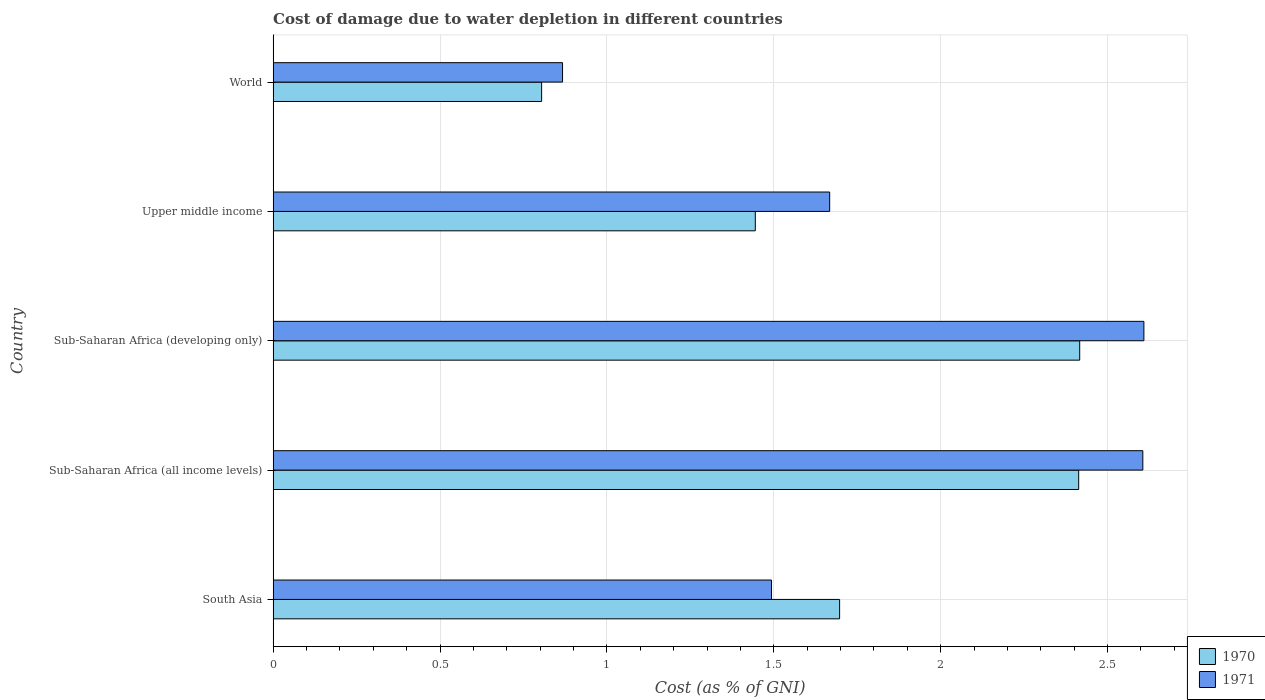How many different coloured bars are there?
Offer a very short reply. 2. Are the number of bars per tick equal to the number of legend labels?
Ensure brevity in your answer.  Yes. How many bars are there on the 2nd tick from the top?
Provide a short and direct response. 2. What is the label of the 4th group of bars from the top?
Make the answer very short. Sub-Saharan Africa (all income levels). What is the cost of damage caused due to water depletion in 1970 in South Asia?
Provide a succinct answer. 1.7. Across all countries, what is the maximum cost of damage caused due to water depletion in 1971?
Your answer should be compact. 2.61. Across all countries, what is the minimum cost of damage caused due to water depletion in 1971?
Keep it short and to the point. 0.87. In which country was the cost of damage caused due to water depletion in 1970 maximum?
Make the answer very short. Sub-Saharan Africa (developing only). What is the total cost of damage caused due to water depletion in 1970 in the graph?
Offer a very short reply. 8.78. What is the difference between the cost of damage caused due to water depletion in 1971 in Sub-Saharan Africa (developing only) and that in World?
Your answer should be compact. 1.74. What is the difference between the cost of damage caused due to water depletion in 1971 in Upper middle income and the cost of damage caused due to water depletion in 1970 in Sub-Saharan Africa (developing only)?
Keep it short and to the point. -0.75. What is the average cost of damage caused due to water depletion in 1971 per country?
Offer a terse response. 1.85. What is the difference between the cost of damage caused due to water depletion in 1971 and cost of damage caused due to water depletion in 1970 in South Asia?
Provide a short and direct response. -0.2. What is the ratio of the cost of damage caused due to water depletion in 1970 in Sub-Saharan Africa (all income levels) to that in Upper middle income?
Provide a succinct answer. 1.67. Is the cost of damage caused due to water depletion in 1970 in South Asia less than that in Upper middle income?
Make the answer very short. No. What is the difference between the highest and the second highest cost of damage caused due to water depletion in 1971?
Provide a short and direct response. 0. What is the difference between the highest and the lowest cost of damage caused due to water depletion in 1971?
Offer a terse response. 1.74. What does the 2nd bar from the top in Sub-Saharan Africa (all income levels) represents?
Ensure brevity in your answer.  1970. Are all the bars in the graph horizontal?
Offer a terse response. Yes. How many countries are there in the graph?
Your answer should be compact. 5. Does the graph contain any zero values?
Offer a terse response. No. Where does the legend appear in the graph?
Make the answer very short. Bottom right. What is the title of the graph?
Your response must be concise. Cost of damage due to water depletion in different countries. What is the label or title of the X-axis?
Your answer should be compact. Cost (as % of GNI). What is the Cost (as % of GNI) in 1970 in South Asia?
Your answer should be very brief. 1.7. What is the Cost (as % of GNI) of 1971 in South Asia?
Give a very brief answer. 1.49. What is the Cost (as % of GNI) in 1970 in Sub-Saharan Africa (all income levels)?
Ensure brevity in your answer.  2.41. What is the Cost (as % of GNI) of 1971 in Sub-Saharan Africa (all income levels)?
Offer a terse response. 2.61. What is the Cost (as % of GNI) of 1970 in Sub-Saharan Africa (developing only)?
Your answer should be compact. 2.42. What is the Cost (as % of GNI) of 1971 in Sub-Saharan Africa (developing only)?
Keep it short and to the point. 2.61. What is the Cost (as % of GNI) in 1970 in Upper middle income?
Make the answer very short. 1.44. What is the Cost (as % of GNI) in 1971 in Upper middle income?
Provide a succinct answer. 1.67. What is the Cost (as % of GNI) of 1970 in World?
Keep it short and to the point. 0.8. What is the Cost (as % of GNI) in 1971 in World?
Offer a very short reply. 0.87. Across all countries, what is the maximum Cost (as % of GNI) in 1970?
Keep it short and to the point. 2.42. Across all countries, what is the maximum Cost (as % of GNI) in 1971?
Your response must be concise. 2.61. Across all countries, what is the minimum Cost (as % of GNI) of 1970?
Your response must be concise. 0.8. Across all countries, what is the minimum Cost (as % of GNI) in 1971?
Keep it short and to the point. 0.87. What is the total Cost (as % of GNI) of 1970 in the graph?
Give a very brief answer. 8.78. What is the total Cost (as % of GNI) in 1971 in the graph?
Offer a very short reply. 9.24. What is the difference between the Cost (as % of GNI) in 1970 in South Asia and that in Sub-Saharan Africa (all income levels)?
Make the answer very short. -0.72. What is the difference between the Cost (as % of GNI) in 1971 in South Asia and that in Sub-Saharan Africa (all income levels)?
Your answer should be very brief. -1.11. What is the difference between the Cost (as % of GNI) of 1970 in South Asia and that in Sub-Saharan Africa (developing only)?
Your answer should be very brief. -0.72. What is the difference between the Cost (as % of GNI) in 1971 in South Asia and that in Sub-Saharan Africa (developing only)?
Provide a succinct answer. -1.12. What is the difference between the Cost (as % of GNI) in 1970 in South Asia and that in Upper middle income?
Offer a very short reply. 0.25. What is the difference between the Cost (as % of GNI) of 1971 in South Asia and that in Upper middle income?
Offer a very short reply. -0.17. What is the difference between the Cost (as % of GNI) in 1970 in South Asia and that in World?
Your response must be concise. 0.89. What is the difference between the Cost (as % of GNI) of 1971 in South Asia and that in World?
Provide a succinct answer. 0.63. What is the difference between the Cost (as % of GNI) of 1970 in Sub-Saharan Africa (all income levels) and that in Sub-Saharan Africa (developing only)?
Offer a terse response. -0. What is the difference between the Cost (as % of GNI) of 1971 in Sub-Saharan Africa (all income levels) and that in Sub-Saharan Africa (developing only)?
Give a very brief answer. -0. What is the difference between the Cost (as % of GNI) of 1970 in Sub-Saharan Africa (all income levels) and that in Upper middle income?
Your response must be concise. 0.97. What is the difference between the Cost (as % of GNI) in 1971 in Sub-Saharan Africa (all income levels) and that in Upper middle income?
Your answer should be compact. 0.94. What is the difference between the Cost (as % of GNI) of 1970 in Sub-Saharan Africa (all income levels) and that in World?
Provide a succinct answer. 1.61. What is the difference between the Cost (as % of GNI) in 1971 in Sub-Saharan Africa (all income levels) and that in World?
Give a very brief answer. 1.74. What is the difference between the Cost (as % of GNI) in 1970 in Sub-Saharan Africa (developing only) and that in Upper middle income?
Your answer should be very brief. 0.97. What is the difference between the Cost (as % of GNI) of 1971 in Sub-Saharan Africa (developing only) and that in Upper middle income?
Your answer should be compact. 0.94. What is the difference between the Cost (as % of GNI) in 1970 in Sub-Saharan Africa (developing only) and that in World?
Ensure brevity in your answer.  1.61. What is the difference between the Cost (as % of GNI) in 1971 in Sub-Saharan Africa (developing only) and that in World?
Your answer should be very brief. 1.74. What is the difference between the Cost (as % of GNI) in 1970 in Upper middle income and that in World?
Provide a succinct answer. 0.64. What is the difference between the Cost (as % of GNI) of 1971 in Upper middle income and that in World?
Your answer should be compact. 0.8. What is the difference between the Cost (as % of GNI) in 1970 in South Asia and the Cost (as % of GNI) in 1971 in Sub-Saharan Africa (all income levels)?
Keep it short and to the point. -0.91. What is the difference between the Cost (as % of GNI) in 1970 in South Asia and the Cost (as % of GNI) in 1971 in Sub-Saharan Africa (developing only)?
Make the answer very short. -0.91. What is the difference between the Cost (as % of GNI) in 1970 in South Asia and the Cost (as % of GNI) in 1971 in Upper middle income?
Your answer should be compact. 0.03. What is the difference between the Cost (as % of GNI) in 1970 in South Asia and the Cost (as % of GNI) in 1971 in World?
Your answer should be compact. 0.83. What is the difference between the Cost (as % of GNI) of 1970 in Sub-Saharan Africa (all income levels) and the Cost (as % of GNI) of 1971 in Sub-Saharan Africa (developing only)?
Give a very brief answer. -0.2. What is the difference between the Cost (as % of GNI) of 1970 in Sub-Saharan Africa (all income levels) and the Cost (as % of GNI) of 1971 in Upper middle income?
Offer a very short reply. 0.75. What is the difference between the Cost (as % of GNI) of 1970 in Sub-Saharan Africa (all income levels) and the Cost (as % of GNI) of 1971 in World?
Offer a very short reply. 1.55. What is the difference between the Cost (as % of GNI) in 1970 in Sub-Saharan Africa (developing only) and the Cost (as % of GNI) in 1971 in Upper middle income?
Ensure brevity in your answer.  0.75. What is the difference between the Cost (as % of GNI) of 1970 in Sub-Saharan Africa (developing only) and the Cost (as % of GNI) of 1971 in World?
Give a very brief answer. 1.55. What is the difference between the Cost (as % of GNI) in 1970 in Upper middle income and the Cost (as % of GNI) in 1971 in World?
Provide a short and direct response. 0.58. What is the average Cost (as % of GNI) in 1970 per country?
Offer a terse response. 1.76. What is the average Cost (as % of GNI) in 1971 per country?
Ensure brevity in your answer.  1.85. What is the difference between the Cost (as % of GNI) in 1970 and Cost (as % of GNI) in 1971 in South Asia?
Make the answer very short. 0.2. What is the difference between the Cost (as % of GNI) of 1970 and Cost (as % of GNI) of 1971 in Sub-Saharan Africa (all income levels)?
Provide a succinct answer. -0.19. What is the difference between the Cost (as % of GNI) in 1970 and Cost (as % of GNI) in 1971 in Sub-Saharan Africa (developing only)?
Your answer should be very brief. -0.19. What is the difference between the Cost (as % of GNI) of 1970 and Cost (as % of GNI) of 1971 in Upper middle income?
Your response must be concise. -0.22. What is the difference between the Cost (as % of GNI) of 1970 and Cost (as % of GNI) of 1971 in World?
Provide a short and direct response. -0.06. What is the ratio of the Cost (as % of GNI) of 1970 in South Asia to that in Sub-Saharan Africa (all income levels)?
Your answer should be very brief. 0.7. What is the ratio of the Cost (as % of GNI) of 1971 in South Asia to that in Sub-Saharan Africa (all income levels)?
Keep it short and to the point. 0.57. What is the ratio of the Cost (as % of GNI) in 1970 in South Asia to that in Sub-Saharan Africa (developing only)?
Offer a very short reply. 0.7. What is the ratio of the Cost (as % of GNI) in 1971 in South Asia to that in Sub-Saharan Africa (developing only)?
Provide a short and direct response. 0.57. What is the ratio of the Cost (as % of GNI) of 1970 in South Asia to that in Upper middle income?
Give a very brief answer. 1.17. What is the ratio of the Cost (as % of GNI) of 1971 in South Asia to that in Upper middle income?
Offer a terse response. 0.9. What is the ratio of the Cost (as % of GNI) of 1970 in South Asia to that in World?
Give a very brief answer. 2.11. What is the ratio of the Cost (as % of GNI) of 1971 in South Asia to that in World?
Provide a succinct answer. 1.72. What is the ratio of the Cost (as % of GNI) of 1971 in Sub-Saharan Africa (all income levels) to that in Sub-Saharan Africa (developing only)?
Ensure brevity in your answer.  1. What is the ratio of the Cost (as % of GNI) of 1970 in Sub-Saharan Africa (all income levels) to that in Upper middle income?
Offer a terse response. 1.67. What is the ratio of the Cost (as % of GNI) in 1971 in Sub-Saharan Africa (all income levels) to that in Upper middle income?
Offer a terse response. 1.56. What is the ratio of the Cost (as % of GNI) in 1970 in Sub-Saharan Africa (all income levels) to that in World?
Provide a short and direct response. 3. What is the ratio of the Cost (as % of GNI) in 1971 in Sub-Saharan Africa (all income levels) to that in World?
Your answer should be compact. 3. What is the ratio of the Cost (as % of GNI) in 1970 in Sub-Saharan Africa (developing only) to that in Upper middle income?
Your response must be concise. 1.67. What is the ratio of the Cost (as % of GNI) of 1971 in Sub-Saharan Africa (developing only) to that in Upper middle income?
Provide a short and direct response. 1.56. What is the ratio of the Cost (as % of GNI) in 1970 in Sub-Saharan Africa (developing only) to that in World?
Your answer should be very brief. 3. What is the ratio of the Cost (as % of GNI) in 1971 in Sub-Saharan Africa (developing only) to that in World?
Keep it short and to the point. 3.01. What is the ratio of the Cost (as % of GNI) in 1970 in Upper middle income to that in World?
Ensure brevity in your answer.  1.8. What is the ratio of the Cost (as % of GNI) of 1971 in Upper middle income to that in World?
Keep it short and to the point. 1.92. What is the difference between the highest and the second highest Cost (as % of GNI) in 1970?
Provide a succinct answer. 0. What is the difference between the highest and the second highest Cost (as % of GNI) of 1971?
Keep it short and to the point. 0. What is the difference between the highest and the lowest Cost (as % of GNI) in 1970?
Offer a terse response. 1.61. What is the difference between the highest and the lowest Cost (as % of GNI) of 1971?
Ensure brevity in your answer.  1.74. 